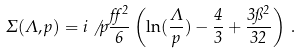<formula> <loc_0><loc_0><loc_500><loc_500>\Sigma ( \Lambda , p ) = i \not \, p \frac { \alpha ^ { 2 } } { 6 } \left ( \ln ( \frac { \Lambda } { p } ) - \frac { 4 } { 3 } + \frac { 3 \pi ^ { 2 } } { 3 2 } \right ) \, .</formula> 